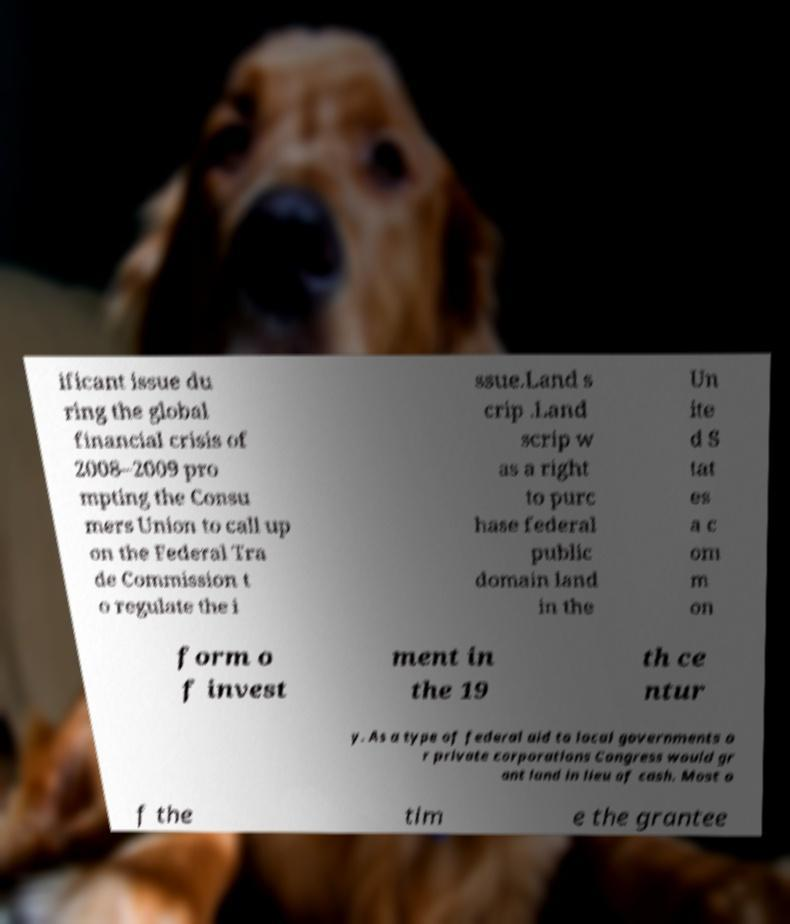Can you read and provide the text displayed in the image?This photo seems to have some interesting text. Can you extract and type it out for me? ificant issue du ring the global financial crisis of 2008–2009 pro mpting the Consu mers Union to call up on the Federal Tra de Commission t o regulate the i ssue.Land s crip .Land scrip w as a right to purc hase federal public domain land in the Un ite d S tat es a c om m on form o f invest ment in the 19 th ce ntur y. As a type of federal aid to local governments o r private corporations Congress would gr ant land in lieu of cash. Most o f the tim e the grantee 